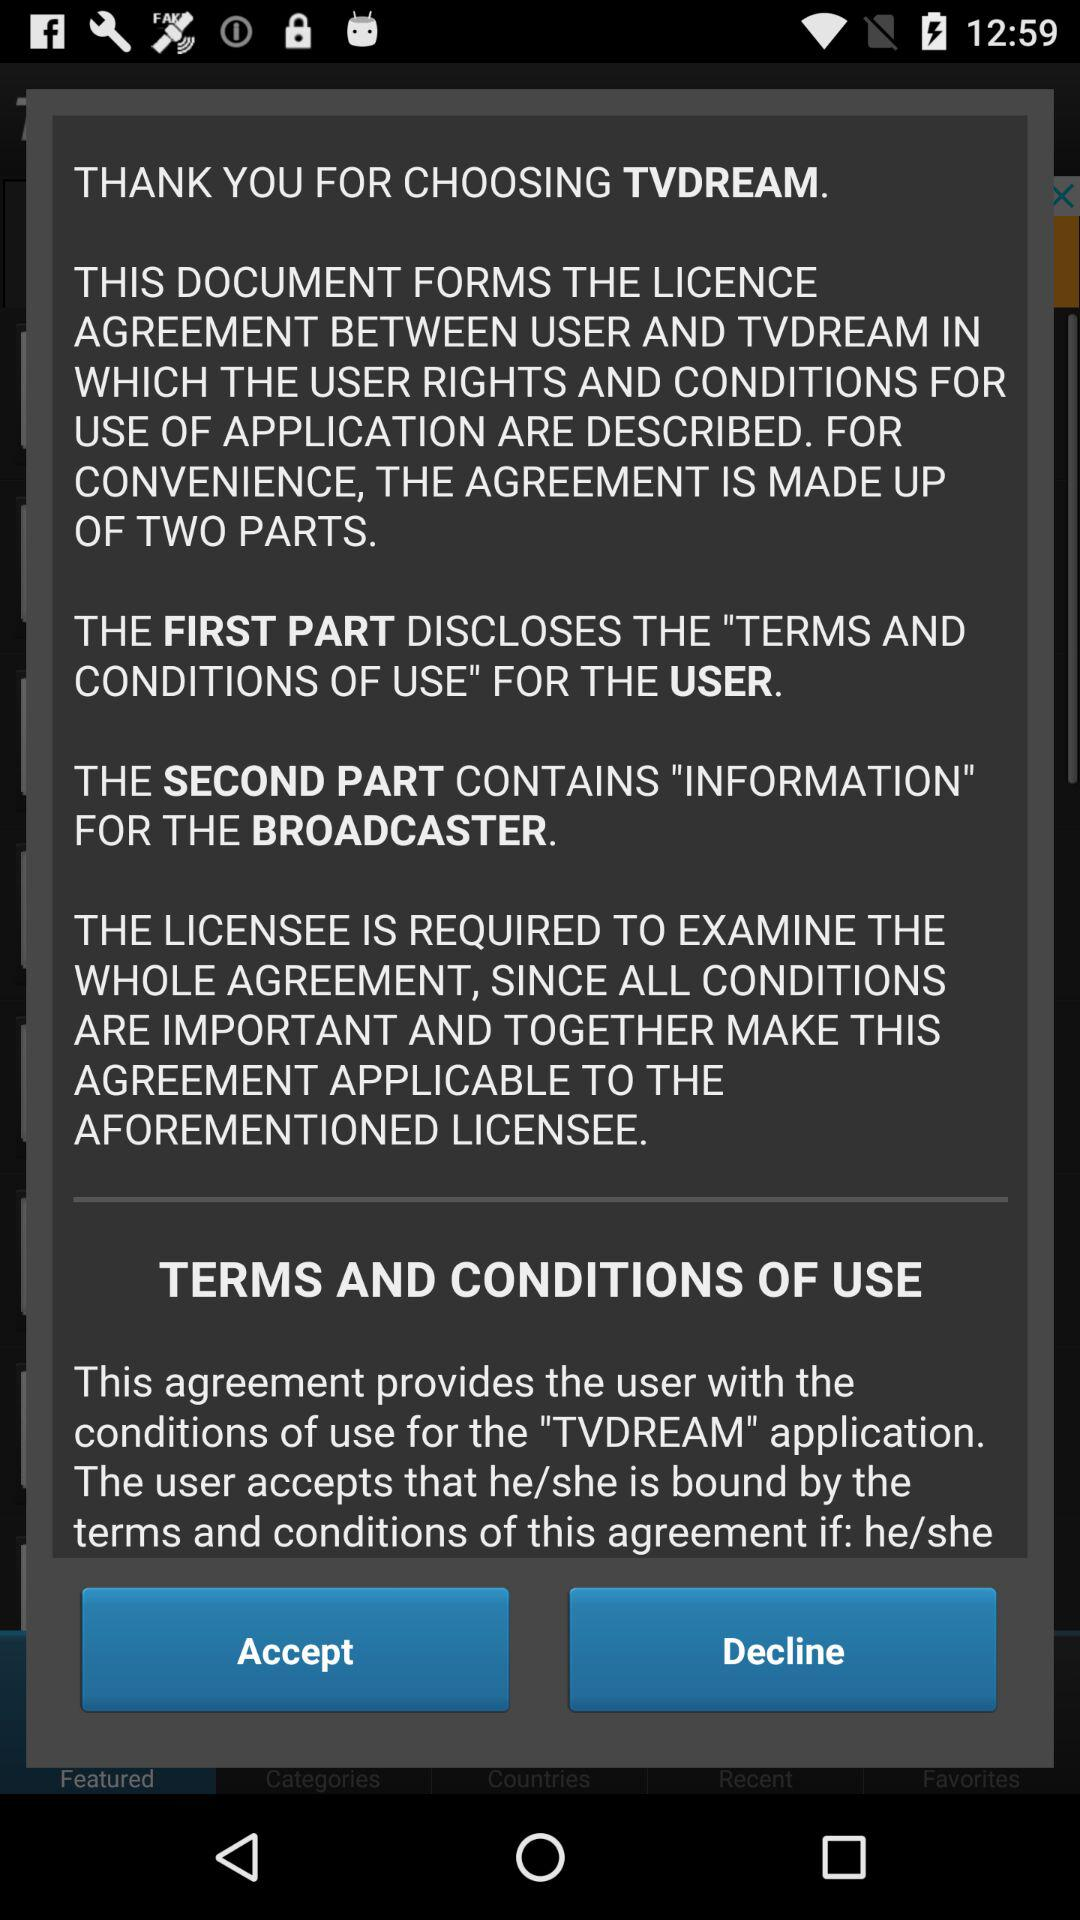What about the first part disclosed? The first part discloses the terms and conditions of use for the user. 